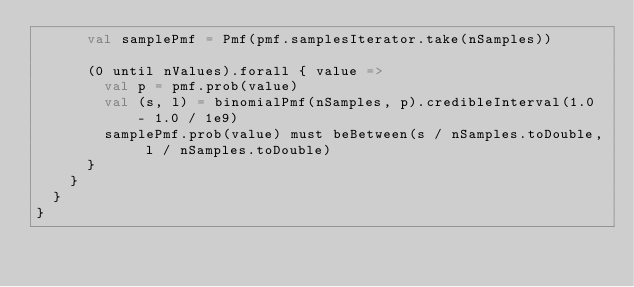<code> <loc_0><loc_0><loc_500><loc_500><_Scala_>      val samplePmf = Pmf(pmf.samplesIterator.take(nSamples))

      (0 until nValues).forall { value =>
        val p = pmf.prob(value)
        val (s, l) = binomialPmf(nSamples, p).credibleInterval(1.0 - 1.0 / 1e9)
        samplePmf.prob(value) must beBetween(s / nSamples.toDouble, l / nSamples.toDouble)
      }
    }
  }
}
</code> 